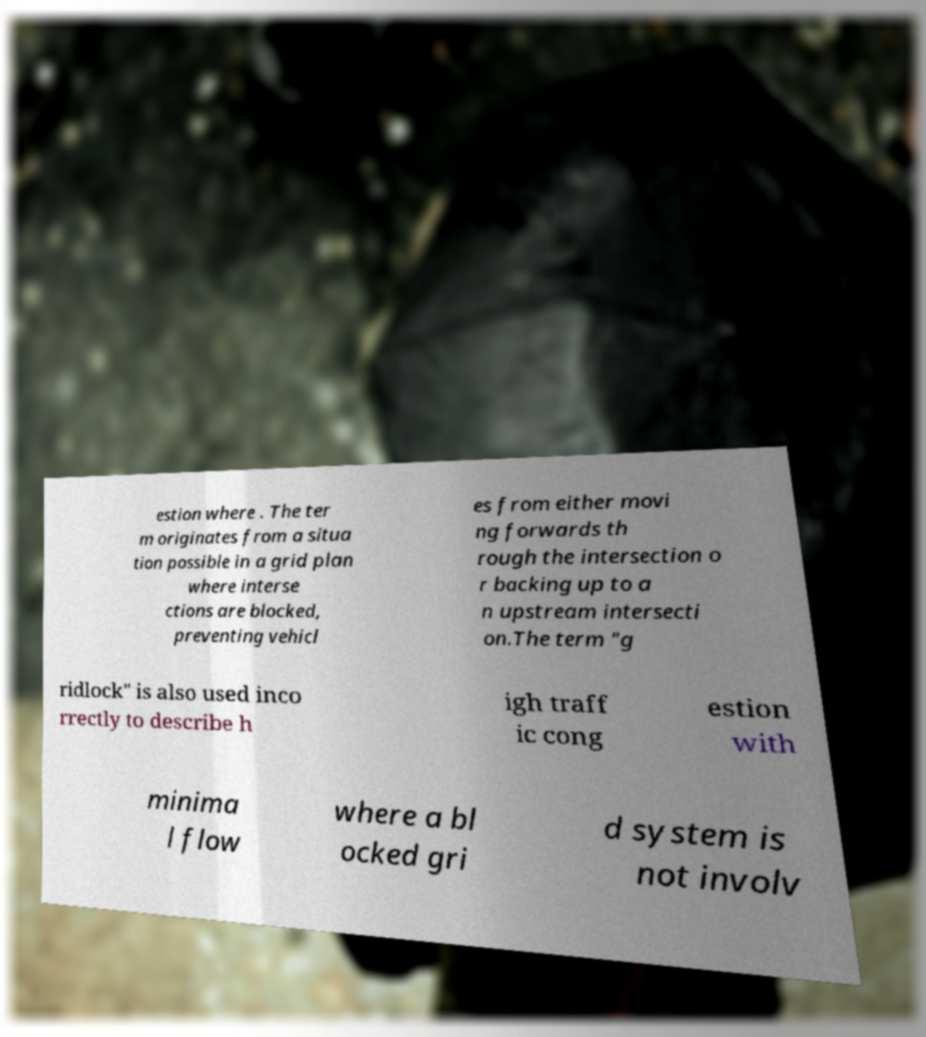Can you read and provide the text displayed in the image?This photo seems to have some interesting text. Can you extract and type it out for me? estion where . The ter m originates from a situa tion possible in a grid plan where interse ctions are blocked, preventing vehicl es from either movi ng forwards th rough the intersection o r backing up to a n upstream intersecti on.The term "g ridlock" is also used inco rrectly to describe h igh traff ic cong estion with minima l flow where a bl ocked gri d system is not involv 